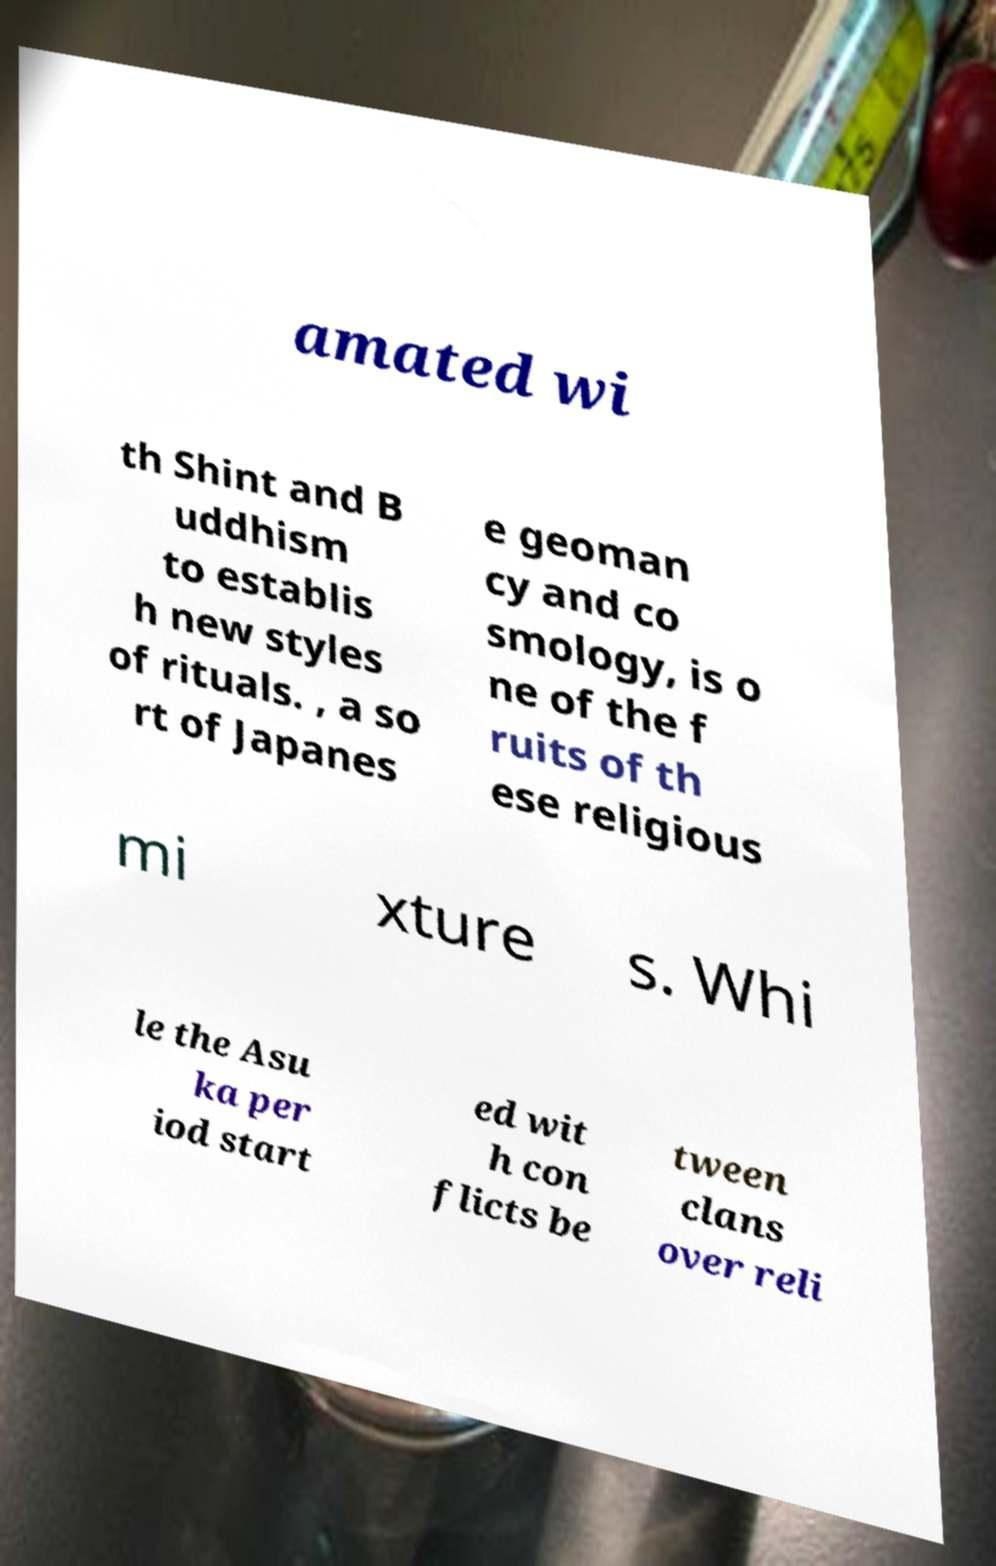Can you read and provide the text displayed in the image?This photo seems to have some interesting text. Can you extract and type it out for me? amated wi th Shint and B uddhism to establis h new styles of rituals. , a so rt of Japanes e geoman cy and co smology, is o ne of the f ruits of th ese religious mi xture s. Whi le the Asu ka per iod start ed wit h con flicts be tween clans over reli 